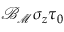<formula> <loc_0><loc_0><loc_500><loc_500>{ \mathcal { B } } _ { { \mathcal { M } } } \sigma _ { z } \tau _ { 0 }</formula> 